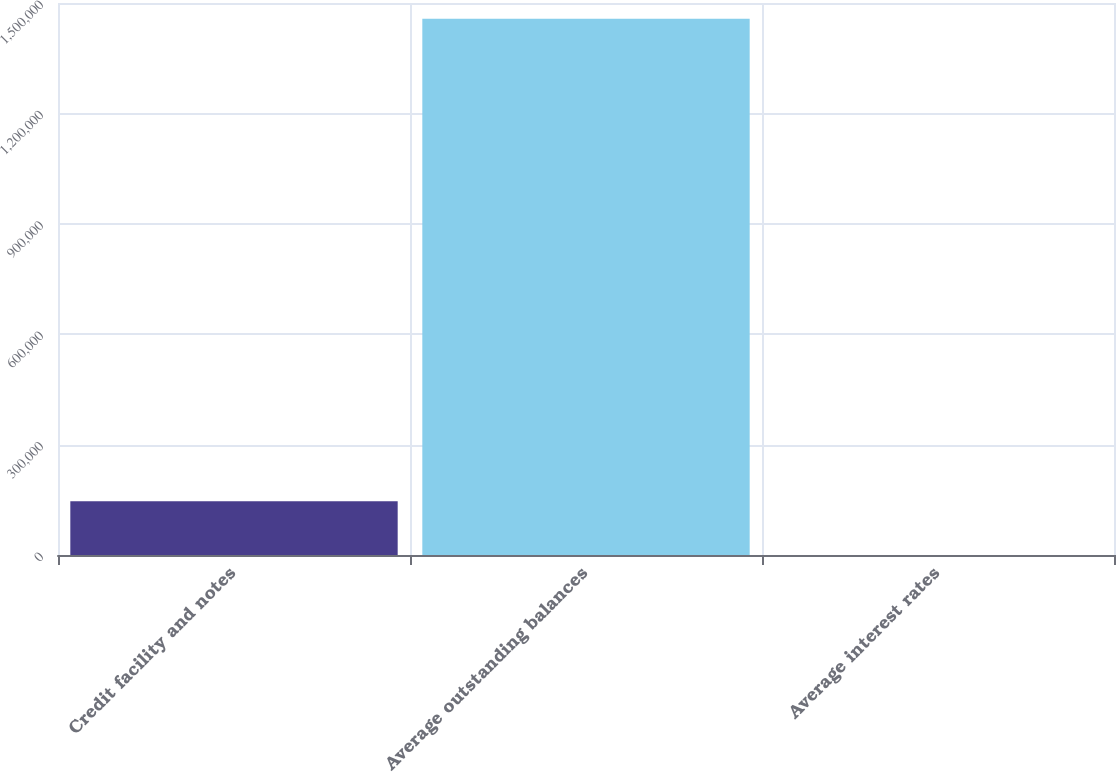Convert chart to OTSL. <chart><loc_0><loc_0><loc_500><loc_500><bar_chart><fcel>Credit facility and notes<fcel>Average outstanding balances<fcel>Average interest rates<nl><fcel>145728<fcel>1.45722e+06<fcel>6.26<nl></chart> 